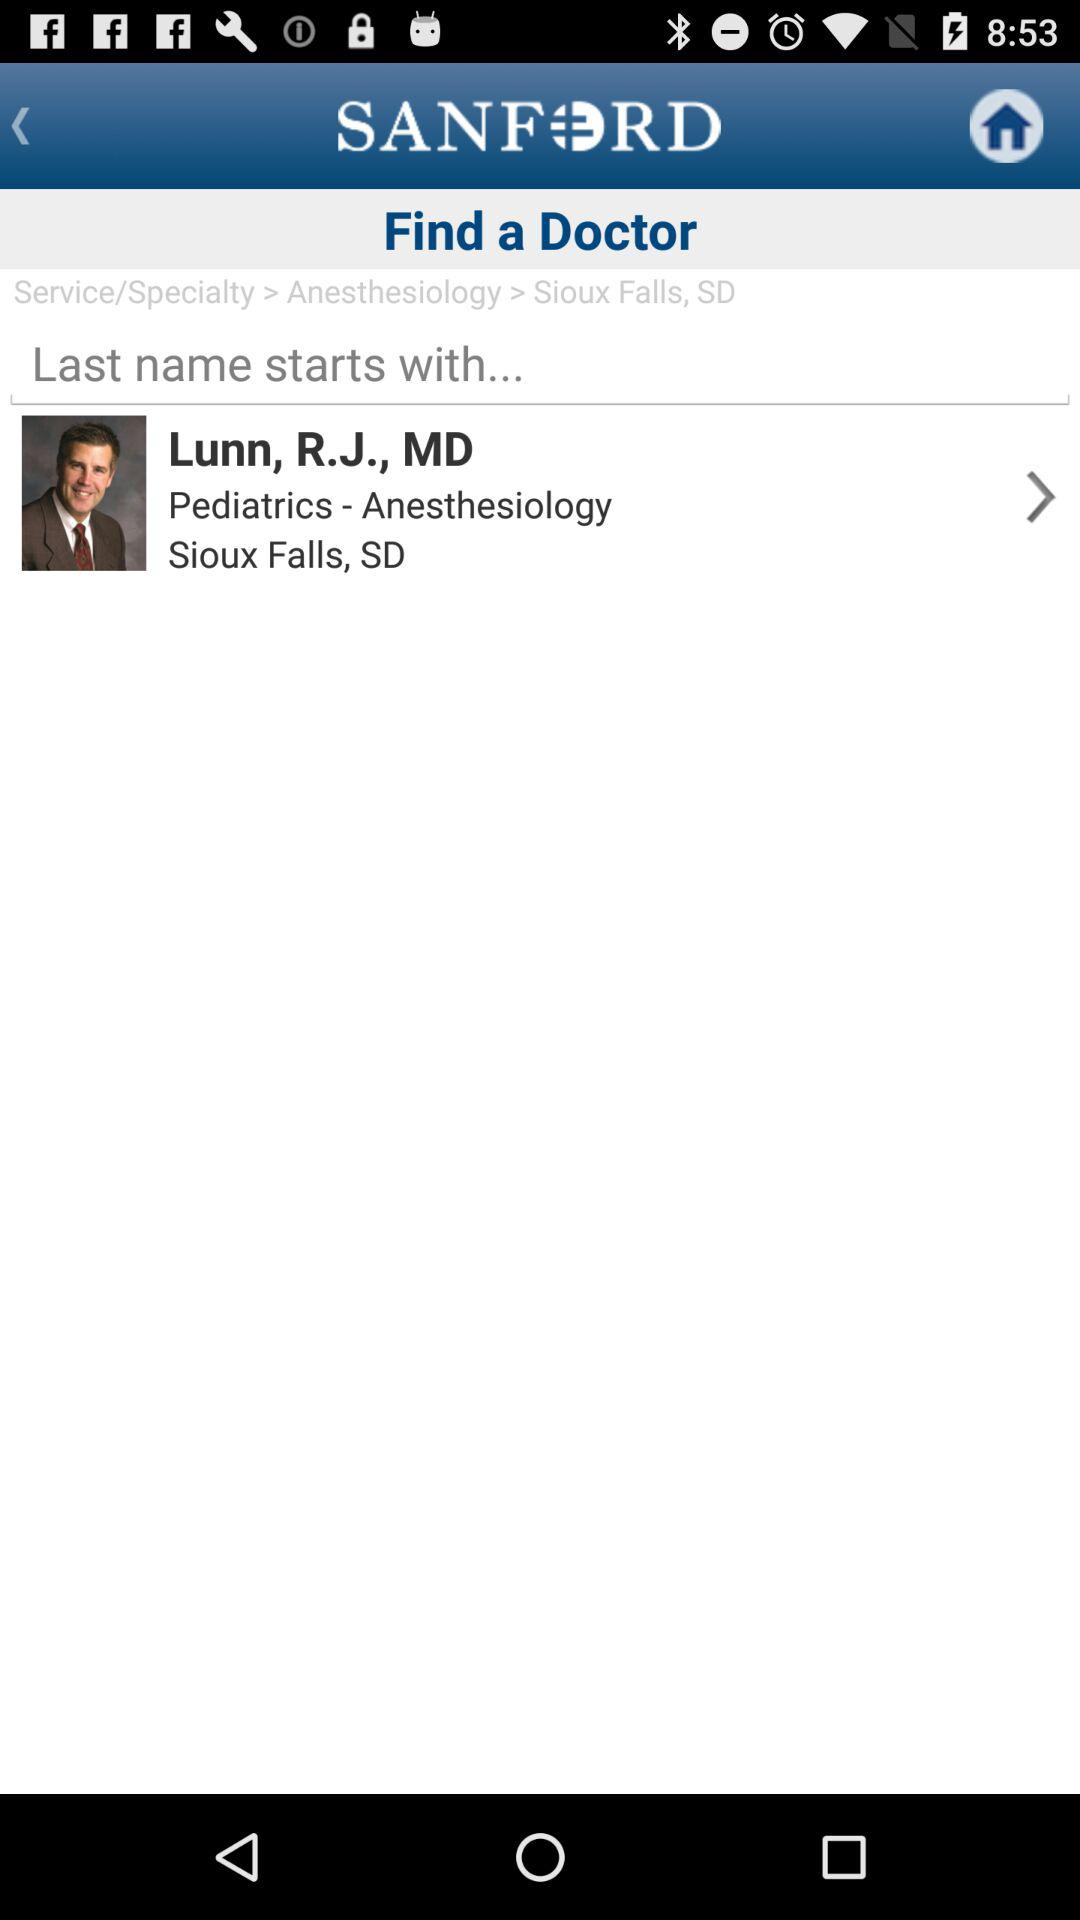What is the application name? The application name is "SANFORD". 